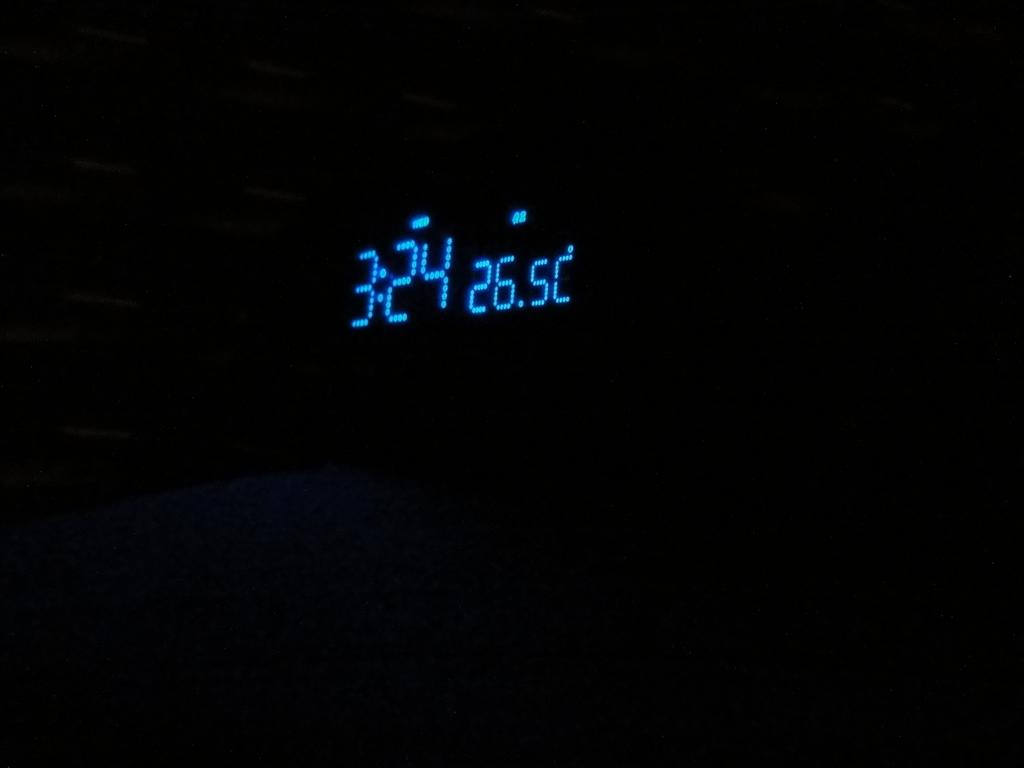<image>
Give a short and clear explanation of the subsequent image. a blue digital clock face displaying the time as 3:24 in a black room 